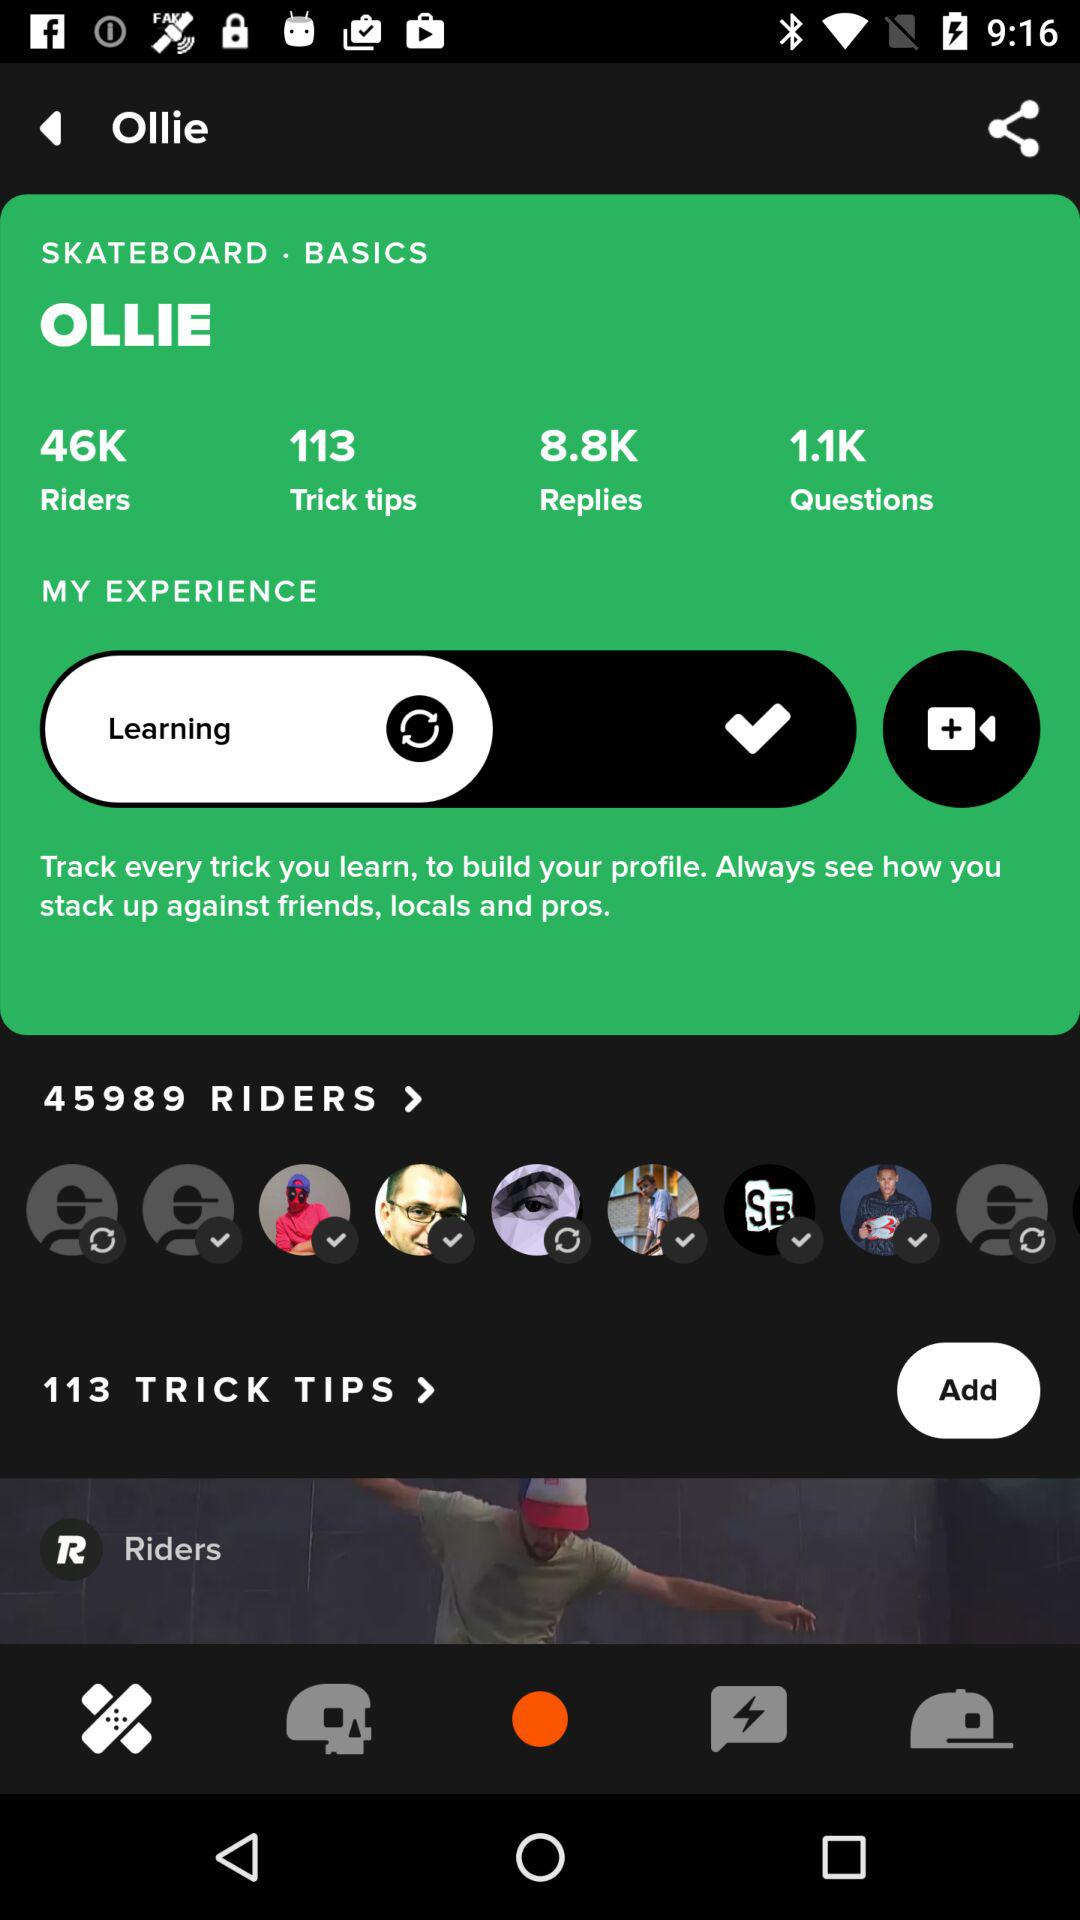How many riders in total are there? There are 45989 riders. 